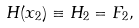<formula> <loc_0><loc_0><loc_500><loc_500>H ( x _ { 2 } ) \equiv H _ { 2 } = F _ { 2 } ,</formula> 